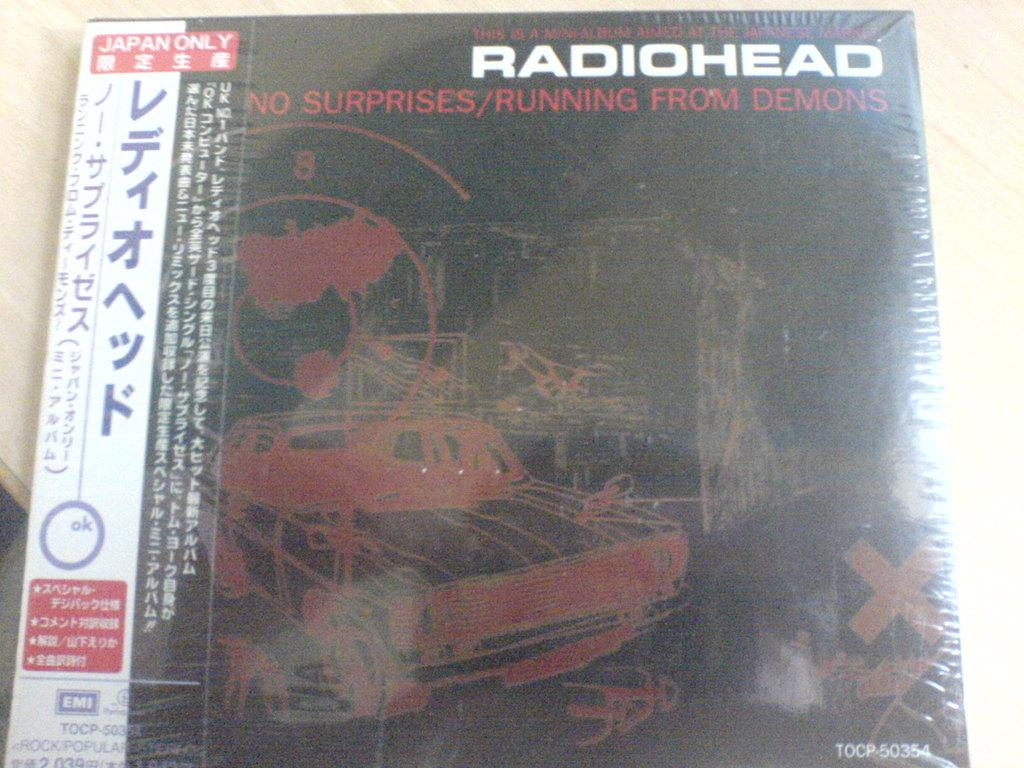<image>
Summarize the visual content of the image. a still shrinkwrapped copy of the japanese release of radiohead's "no surprises" single 